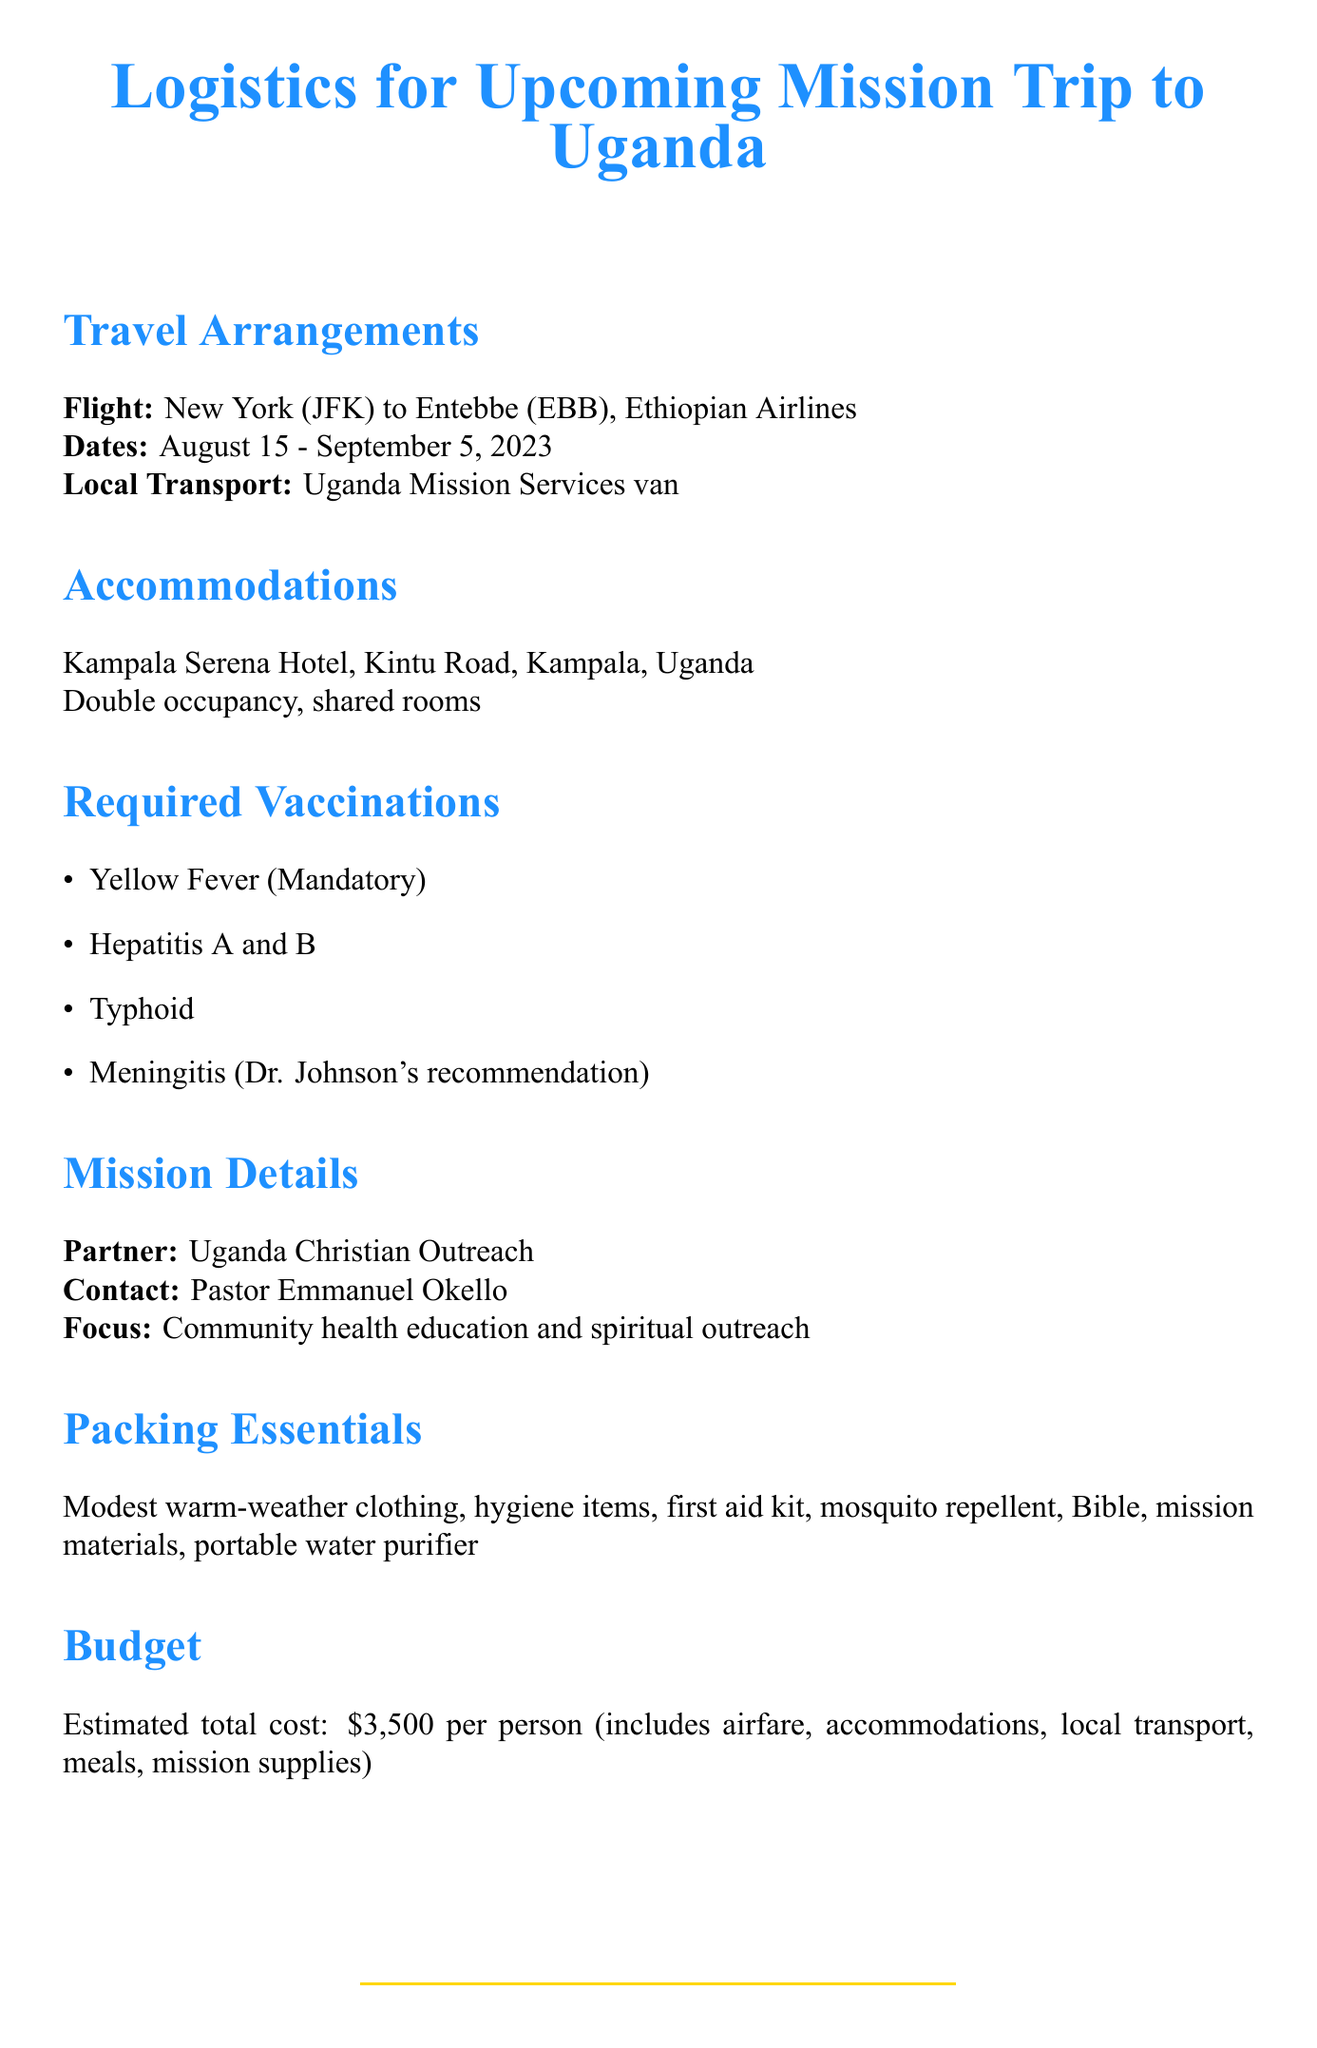What is the departure date for the mission trip? The departure date is explicitly stated in the travel arrangements section as August 15, 2023.
Answer: August 15, 2023 Who is the primary contact for the mission? The primary contact is mentioned under mission details, specifically as Pastor Emmanuel Okello.
Answer: Pastor Emmanuel Okello What vaccinations are required for entry into Uganda? The memo lists Yellow Fever as mandatory for entry into Uganda under the required vaccinations section.
Answer: Yellow Fever What hotel will the team stay at during the mission trip? The accommodations section specifies that the team will stay at Kampala Serena Hotel.
Answer: Kampala Serena Hotel What is the estimated total cost per person for the trip? The budget considerations indicate that the estimated total cost is $3,500 per person.
Answer: $3,500 What type of transportation will be provided in Uganda? Local transportation details state that Uganda Mission Services will provide van transportation.
Answer: Van transportation When is the vaccine deadline? The important dates section notes the vaccine deadline as July 15, 2023.
Answer: July 15, 2023 What communication method will be used for team discussions? The communication plan details that a WhatsApp group will be used for team communication.
Answer: WhatsApp group 